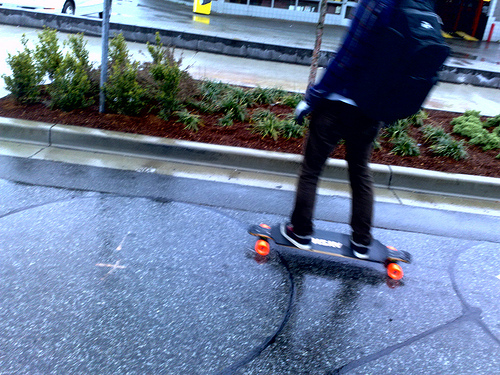<image>
Is the backpack on the floor? No. The backpack is not positioned on the floor. They may be near each other, but the backpack is not supported by or resting on top of the floor. 